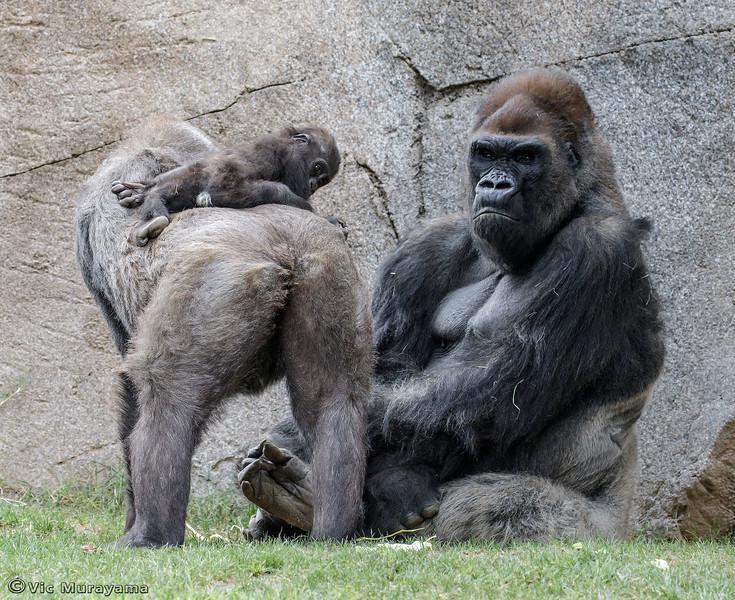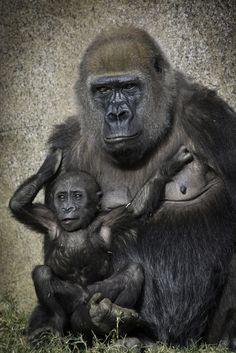The first image is the image on the left, the second image is the image on the right. Considering the images on both sides, is "One image contains a group of three apes, and the other image features one adult gorilla sitting with a baby gorilla that is on the adult's chest and facing forward." valid? Answer yes or no. Yes. 